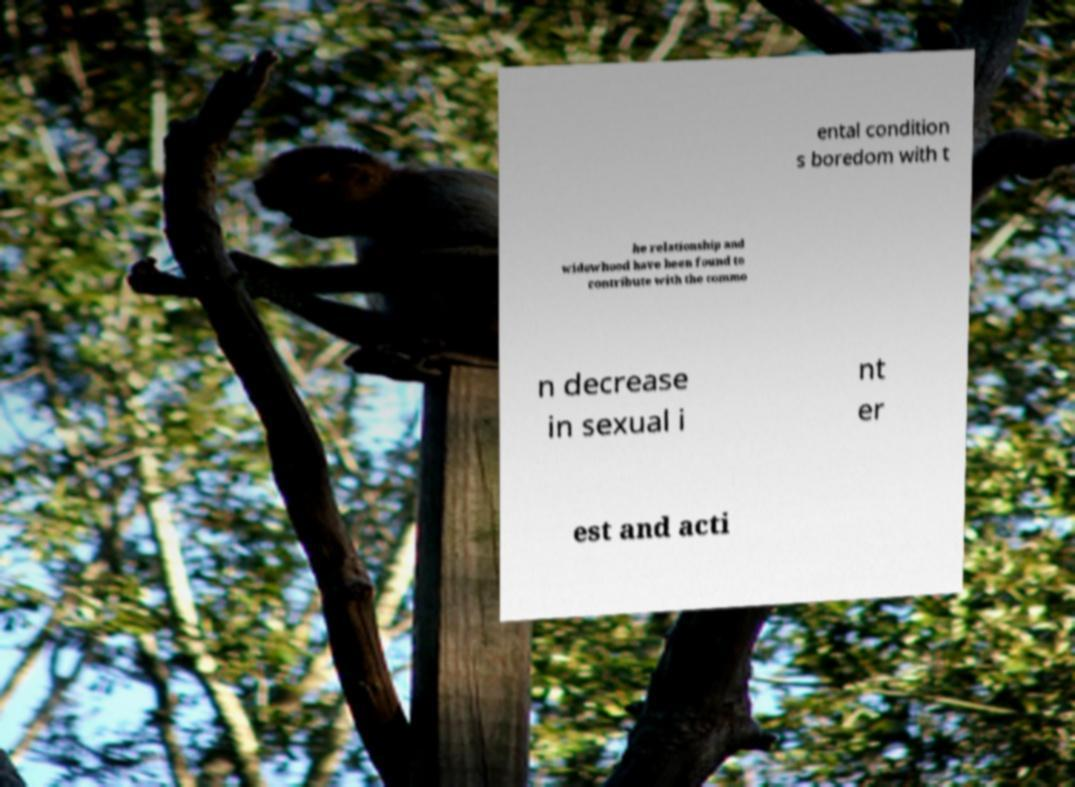Please read and relay the text visible in this image. What does it say? ental condition s boredom with t he relationship and widowhood have been found to contribute with the commo n decrease in sexual i nt er est and acti 